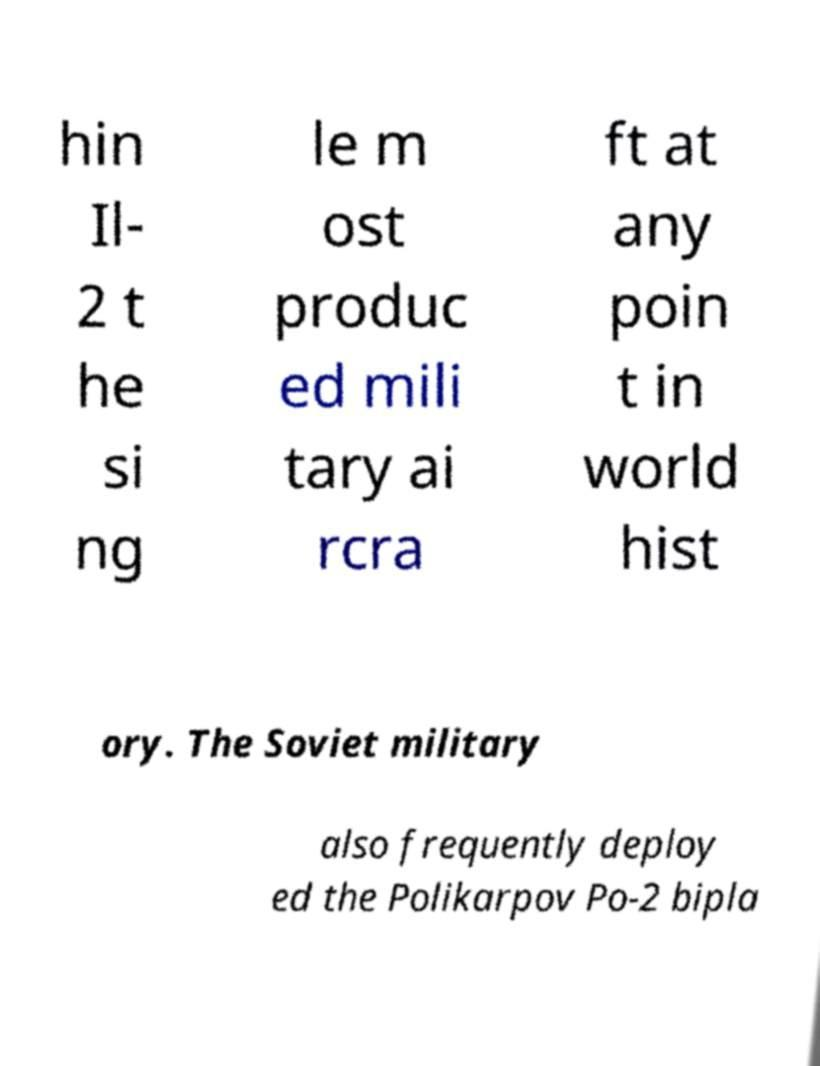There's text embedded in this image that I need extracted. Can you transcribe it verbatim? hin Il- 2 t he si ng le m ost produc ed mili tary ai rcra ft at any poin t in world hist ory. The Soviet military also frequently deploy ed the Polikarpov Po-2 bipla 